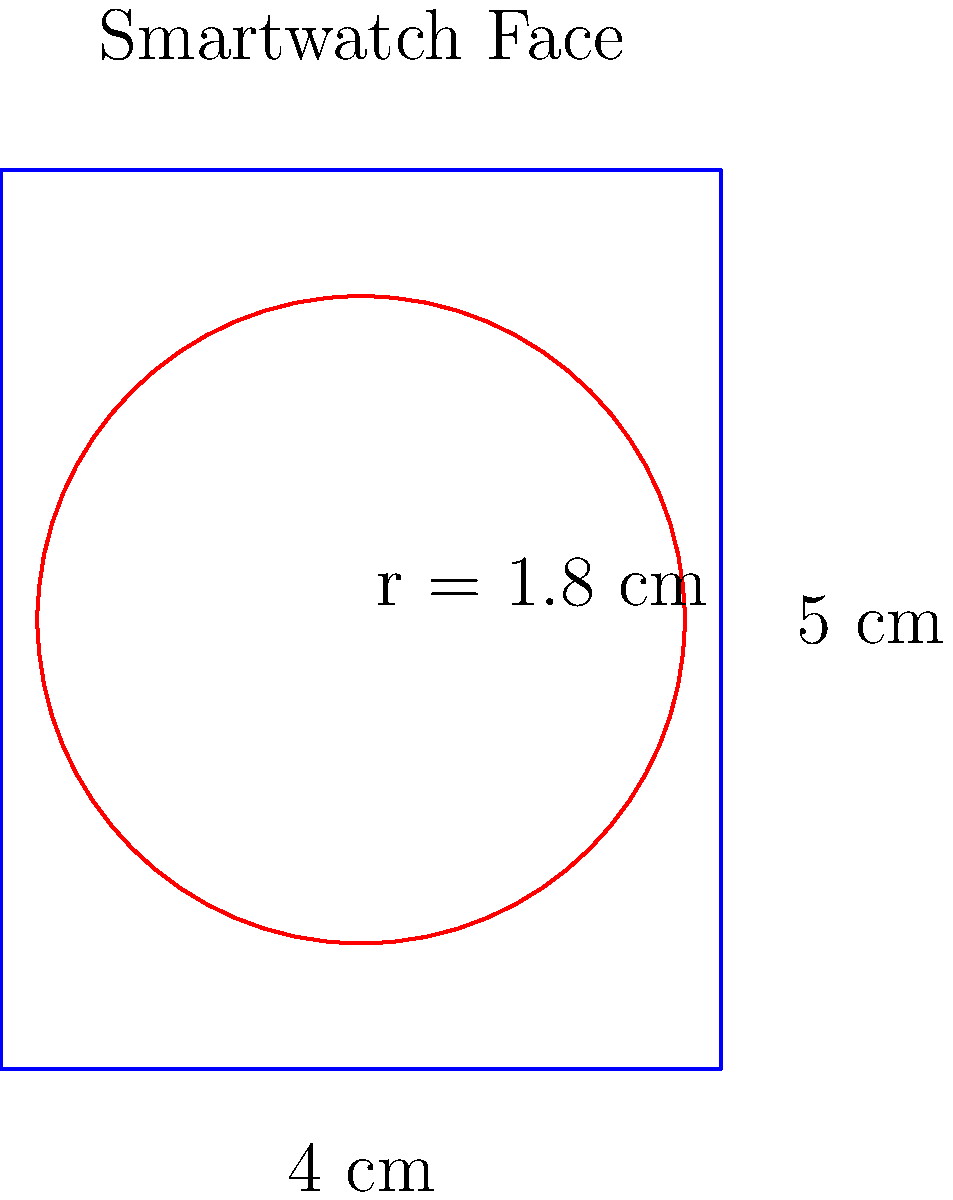A new smartwatch design features a rectangular face with a circular display area. The face measures 4 cm wide by 5 cm tall, and the circular display has a radius of 1.8 cm. What is the total surface area of the smartwatch face that is not part of the circular display, rounded to two decimal places? To solve this problem, we need to follow these steps:

1. Calculate the area of the rectangular smartwatch face:
   $$A_{rectangle} = width \times height = 4 \text{ cm} \times 5 \text{ cm} = 20 \text{ cm}^2$$

2. Calculate the area of the circular display:
   $$A_{circle} = \pi r^2 = \pi \times (1.8 \text{ cm})^2 = 10.18 \text{ cm}^2$$

3. Subtract the area of the circular display from the total rectangular area:
   $$A_{remaining} = A_{rectangle} - A_{circle}$$
   $$A_{remaining} = 20 \text{ cm}^2 - 10.18 \text{ cm}^2 = 9.82 \text{ cm}^2$$

4. Round the result to two decimal places:
   $$A_{remaining} \approx 9.82 \text{ cm}^2$$

This calculation gives us the surface area of the smartwatch face that is not part of the circular display, which is relevant for evaluating the design and potential placement of additional sensors or components in wearable health monitors.
Answer: 9.82 cm² 